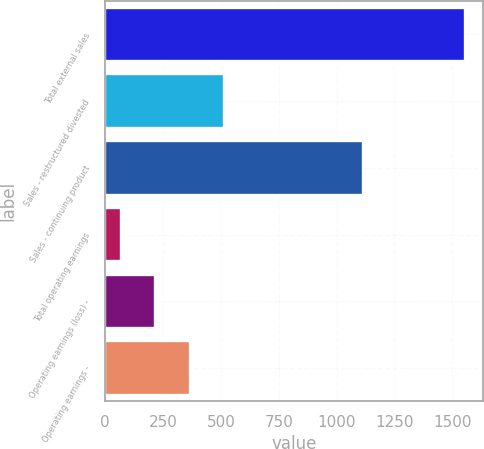Convert chart to OTSL. <chart><loc_0><loc_0><loc_500><loc_500><bar_chart><fcel>Total external sales<fcel>Sales - restructured divested<fcel>Sales - continuing product<fcel>Total operating earnings<fcel>Operating earnings (loss) -<fcel>Operating earnings -<nl><fcel>1554<fcel>513.1<fcel>1113<fcel>67<fcel>215.7<fcel>364.4<nl></chart> 